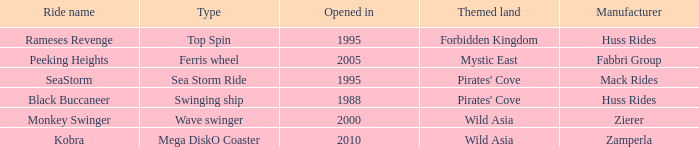Which ride opened after the 2000 Peeking Heights? Ferris wheel. 